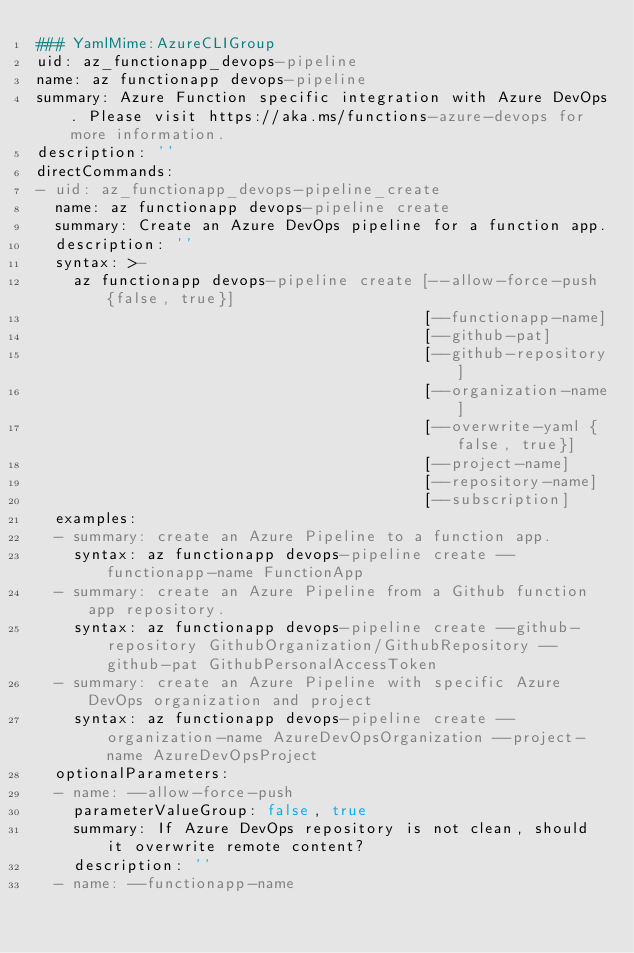<code> <loc_0><loc_0><loc_500><loc_500><_YAML_>### YamlMime:AzureCLIGroup
uid: az_functionapp_devops-pipeline
name: az functionapp devops-pipeline
summary: Azure Function specific integration with Azure DevOps. Please visit https://aka.ms/functions-azure-devops for more information.
description: ''
directCommands:
- uid: az_functionapp_devops-pipeline_create
  name: az functionapp devops-pipeline create
  summary: Create an Azure DevOps pipeline for a function app.
  description: ''
  syntax: >-
    az functionapp devops-pipeline create [--allow-force-push {false, true}]
                                          [--functionapp-name]
                                          [--github-pat]
                                          [--github-repository]
                                          [--organization-name]
                                          [--overwrite-yaml {false, true}]
                                          [--project-name]
                                          [--repository-name]
                                          [--subscription]
  examples:
  - summary: create an Azure Pipeline to a function app.
    syntax: az functionapp devops-pipeline create --functionapp-name FunctionApp
  - summary: create an Azure Pipeline from a Github function app repository.
    syntax: az functionapp devops-pipeline create --github-repository GithubOrganization/GithubRepository --github-pat GithubPersonalAccessToken
  - summary: create an Azure Pipeline with specific Azure DevOps organization and project
    syntax: az functionapp devops-pipeline create --organization-name AzureDevOpsOrganization --project-name AzureDevOpsProject
  optionalParameters:
  - name: --allow-force-push
    parameterValueGroup: false, true
    summary: If Azure DevOps repository is not clean, should it overwrite remote content?
    description: ''
  - name: --functionapp-name</code> 